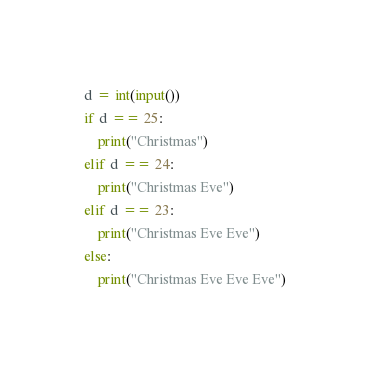Convert code to text. <code><loc_0><loc_0><loc_500><loc_500><_Python_>d = int(input())
if d == 25:
    print("Christmas")
elif d == 24:
    print("Christmas Eve")
elif d == 23:
    print("Christmas Eve Eve")
else:
    print("Christmas Eve Eve Eve")
</code> 